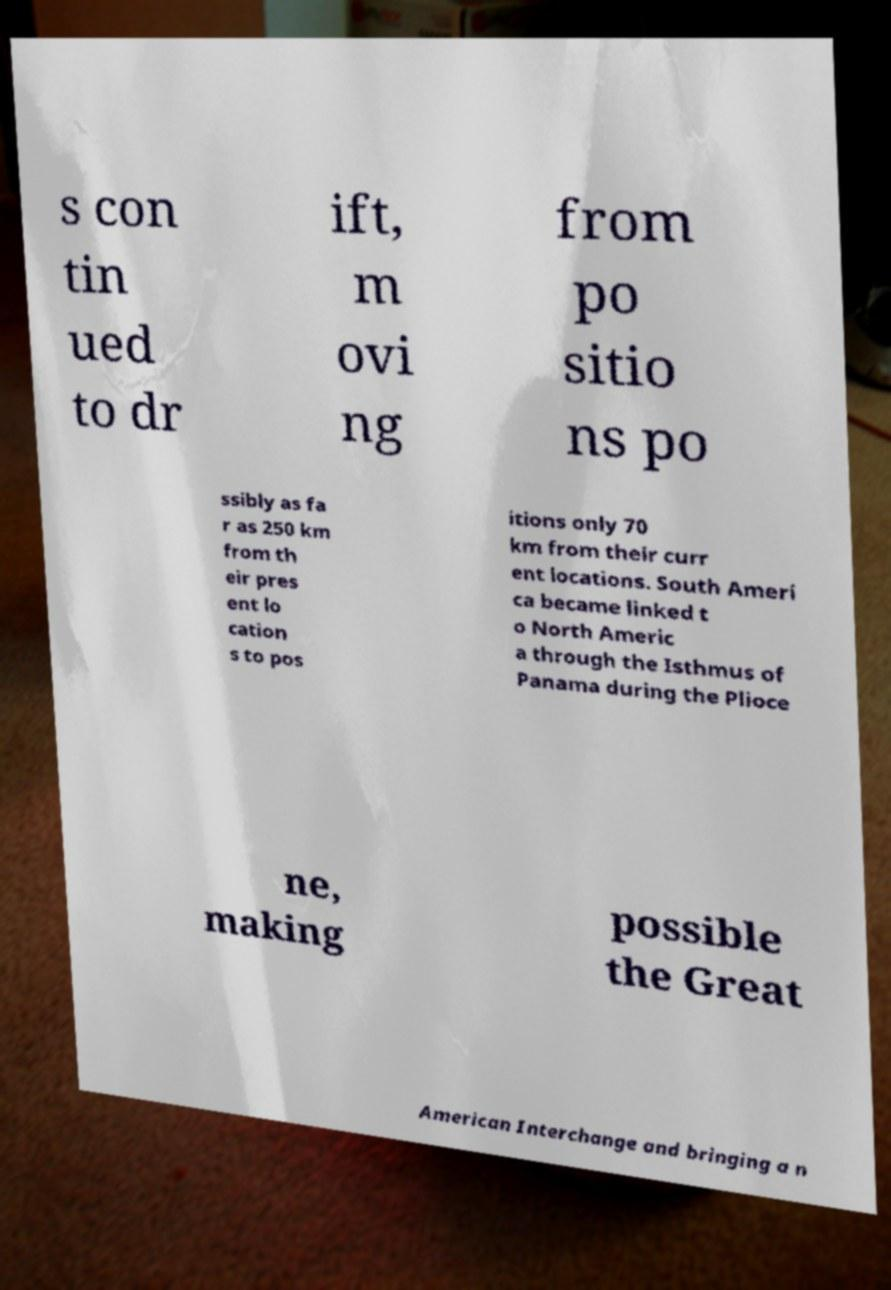Could you extract and type out the text from this image? s con tin ued to dr ift, m ovi ng from po sitio ns po ssibly as fa r as 250 km from th eir pres ent lo cation s to pos itions only 70 km from their curr ent locations. South Ameri ca became linked t o North Americ a through the Isthmus of Panama during the Plioce ne, making possible the Great American Interchange and bringing a n 